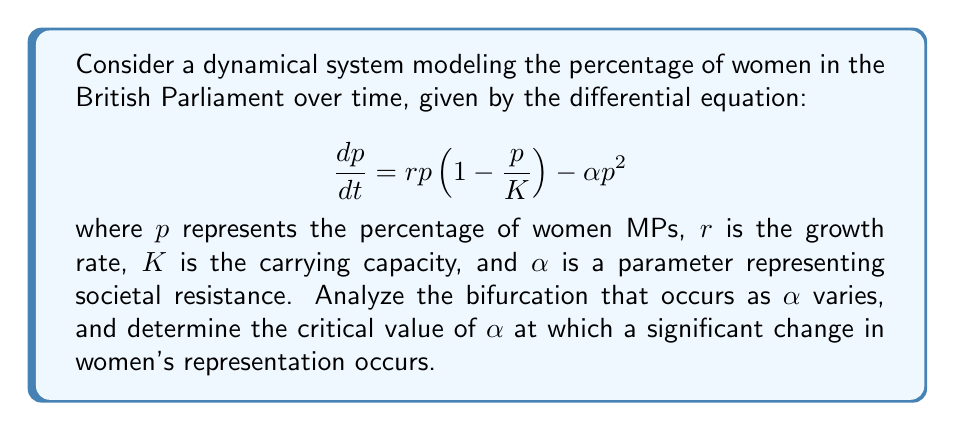Could you help me with this problem? 1. First, find the equilibrium points by setting $\frac{dp}{dt} = 0$:
   $$r p (1 - \frac{p}{K}) - \alpha p^2 = 0$$

2. Factor out $p$:
   $$p(r (1 - \frac{p}{K}) - \alpha p) = 0$$

3. Solve for $p$:
   $p = 0$ or $r (1 - \frac{p}{K}) - \alpha p = 0$

4. For the non-zero equilibrium, rearrange:
   $$r - \frac{r}{K}p - \alpha p = 0$$
   $$p(\frac{r}{K} + \alpha) = r$$
   $$p = \frac{r}{\frac{r}{K} + \alpha} = \frac{rK}{r + \alpha K}$$

5. The non-zero equilibrium exists when $\frac{rK}{r + \alpha K} > 0$, which is always true for positive parameters.

6. To find the bifurcation point, analyze the stability of the equilibria:
   The Jacobian is $J = \frac{d}{dp}(\frac{dp}{dt}) = r(1 - \frac{2p}{K}) - 2\alpha p$

7. At $p = 0$, $J = r$. This equilibrium is unstable when $r > 0$.

8. At $p = \frac{rK}{r + \alpha K}$, substitute into $J$:
   $$J = r(1 - \frac{2rK}{(r + \alpha K)K}) - 2\alpha \frac{rK}{r + \alpha K}$$
   $$= r - \frac{2r^2}{r + \alpha K} - \frac{2\alpha rK}{r + \alpha K}$$
   $$= \frac{r(r + \alpha K) - 2r^2 - 2\alpha rK}{r + \alpha K}$$
   $$= \frac{r^2 + \alpha rK - 2r^2 - 2\alpha rK}{r + \alpha K}$$
   $$= \frac{-r^2 - \alpha rK}{r + \alpha K} = -r$$

9. The non-zero equilibrium changes stability when $J = 0$, which occurs when $r = 0$.

10. However, $r = 0$ is not interesting for our model. The bifurcation we're interested in occurs when the non-zero equilibrium equals the carrying capacity $K$:

    $$\frac{rK}{r + \alpha K} = K$$

11. Solve for $\alpha$:
    $$rK = K(r + \alpha K)$$
    $$rK = rK + \alpha K^2$$
    $$0 = \alpha K^2$$
    $$\alpha = 0$$

12. Therefore, the critical value of $\alpha$ is 0. When $\alpha > 0$, the equilibrium percentage of women MPs is less than the carrying capacity $K$, representing societal resistance. When $\alpha = 0$, the model reduces to the logistic growth model, allowing women's representation to reach the carrying capacity.
Answer: $\alpha_{critical} = 0$ 